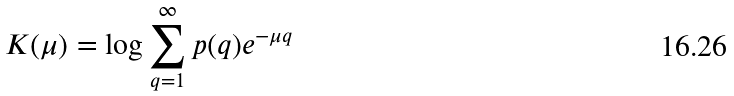Convert formula to latex. <formula><loc_0><loc_0><loc_500><loc_500>K ( \mu ) = \log \sum _ { q = 1 } ^ { \infty } p ( q ) e ^ { - \mu q }</formula> 